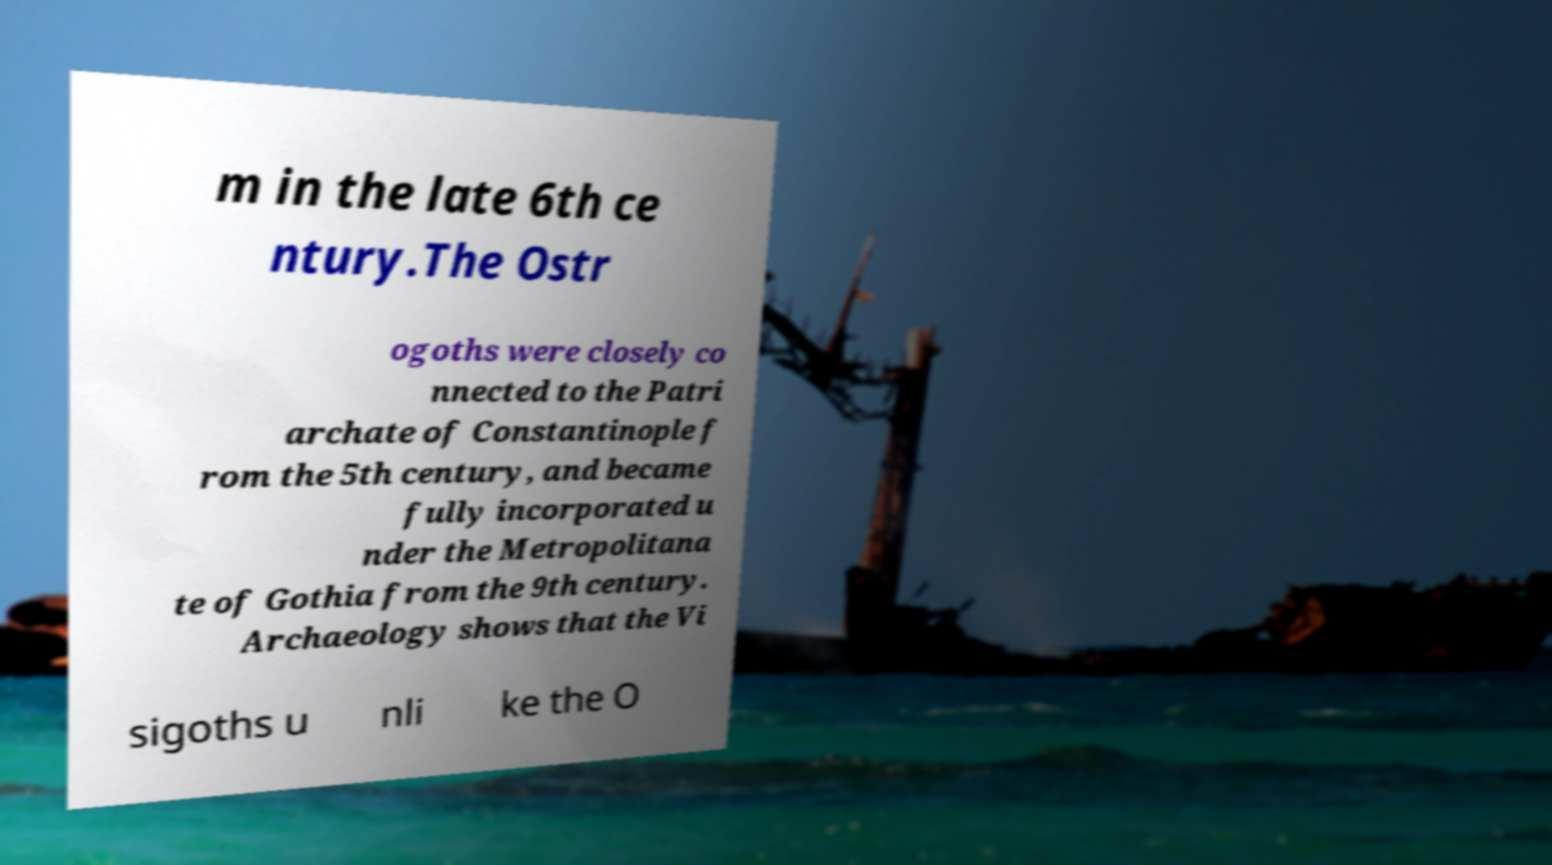Please read and relay the text visible in this image. What does it say? m in the late 6th ce ntury.The Ostr ogoths were closely co nnected to the Patri archate of Constantinople f rom the 5th century, and became fully incorporated u nder the Metropolitana te of Gothia from the 9th century. Archaeology shows that the Vi sigoths u nli ke the O 